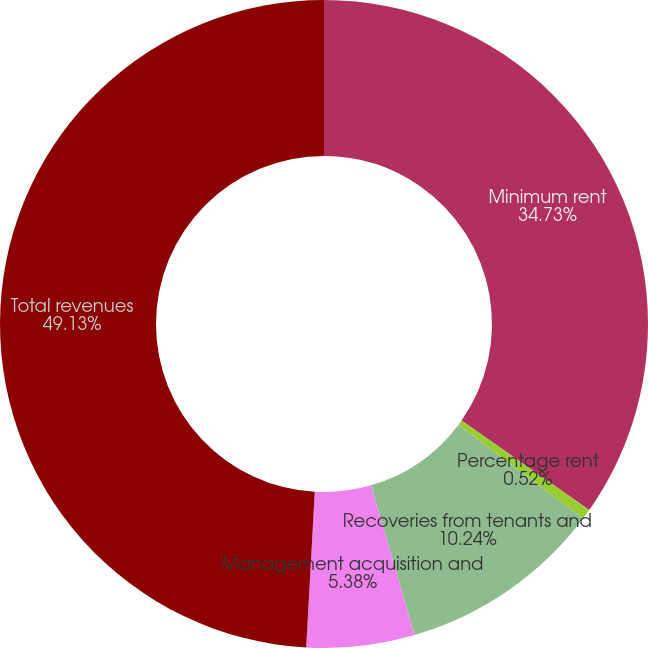Convert chart to OTSL. <chart><loc_0><loc_0><loc_500><loc_500><pie_chart><fcel>Minimum rent<fcel>Percentage rent<fcel>Recoveries from tenants and<fcel>Management acquisition and<fcel>Total revenues<nl><fcel>34.73%<fcel>0.52%<fcel>10.24%<fcel>5.38%<fcel>49.12%<nl></chart> 